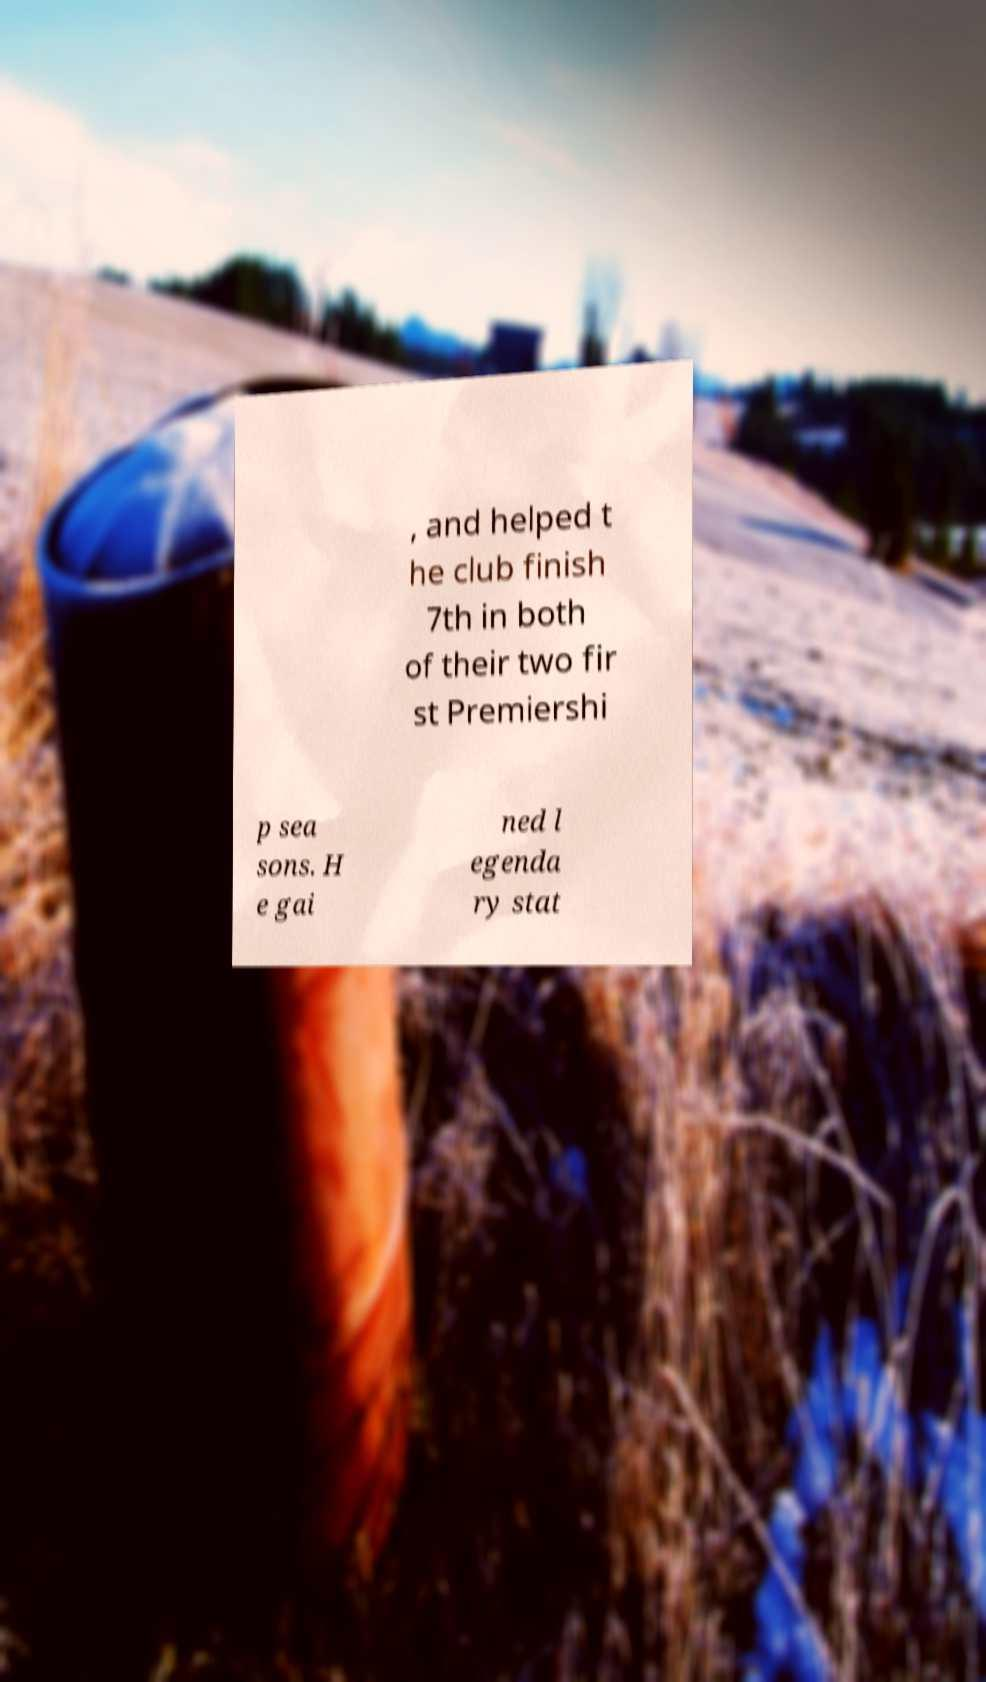There's text embedded in this image that I need extracted. Can you transcribe it verbatim? , and helped t he club finish 7th in both of their two fir st Premiershi p sea sons. H e gai ned l egenda ry stat 